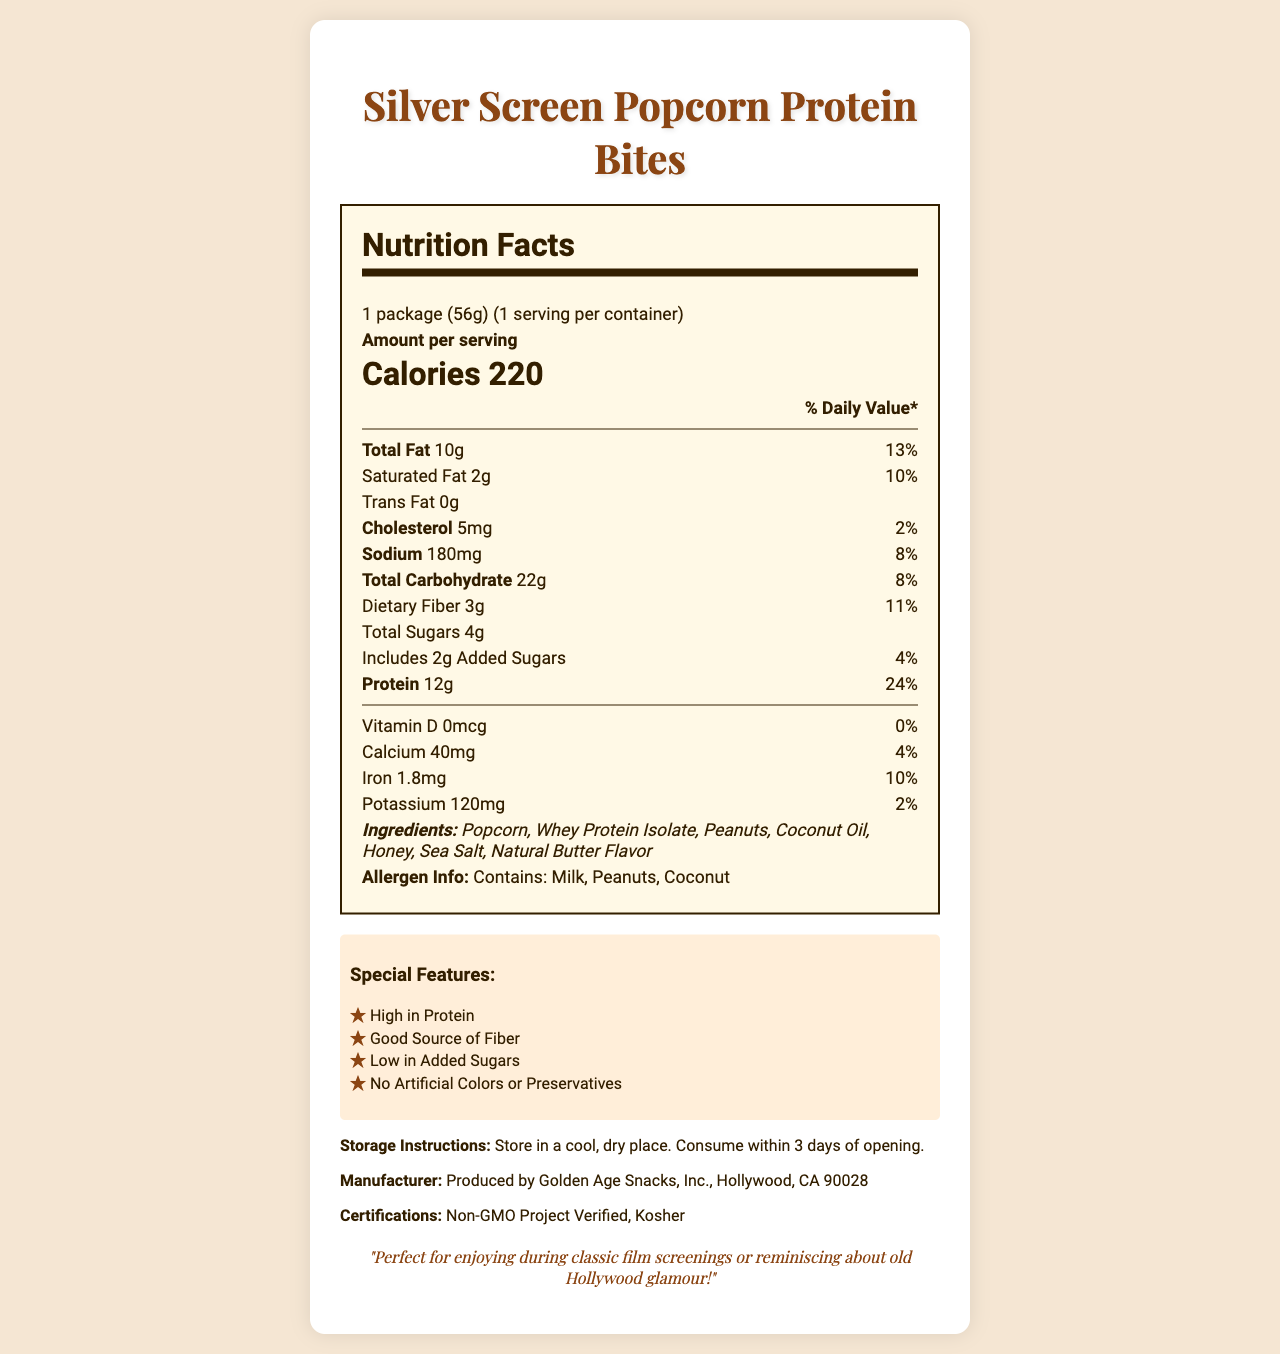what is the serving size of Silver Screen Popcorn Protein Bites? The serving size is specified directly in the Nutrition Facts Label at the top section.
Answer: 1 package (56g) how many calories are in one serving? The amount of calories per serving is highlighted in larger text under the "Amount per serving" section.
Answer: 220 calories what are the three main allergens in this product? The allergen info at the bottom of the Nutrition Facts Label explicitly states "Contains: Milk, Peanuts, Coconut".
Answer: Milk, Peanuts, Coconut what is the total fat content per serving? The total fat content is provided near the top of the label, stating "Total Fat 10g".
Answer: 10g how much protein does one serving contain? The document specifies "Protein 12g" under the nutrition facts, alongside the % Daily Value.
Answer: 12g which of the following is a special feature of the product? A. Contains Artificial Colors B. Low in Protein C. No Artificial Colors or Preservatives D. High in Added Sugars The special features listed include "No Artificial Colors or Preservatives" among other benefits.
Answer: C what is the daily value percentage of iron per serving? The daily value percentage for iron is listed on the label as "Iron 1.8mg" and "10%" in the vitamin and mineral section.
Answer: 10% True or False: This product includes artificial preservatives. Under the special features section, it states "No Artificial Colors or Preservatives".
Answer: False where is the manufacturer located? The manufacturer's information specifies "Golden Age Snacks, Inc., Hollywood, CA 90028".
Answer: Hollywood, CA 90028 how many grams of dietary fiber does this product contain? The nutritional label indicates "Dietary Fiber 3g", with an 11% daily value.
Answer: 3g does this product contain any added sugars? If yes, how many grams? The label indicates "Includes 2g Added Sugars" under the Total Sugars section.
Answer: Yes, 2g summarize the main features and highlights of the Silver Screen Popcorn Protein Bites. The summary covers the serving size, calorie content, protein and fiber amounts, special features, allergens, manufacturers, and certifications.
Answer: The Silver Screen Popcorn Protein Bites come in a 56g package and contain 220 calories per serving. They are high in protein (12g) and a good source of dietary fiber (3g) with low added sugars (2g). The product has no artificial colors or preservatives and contains allergens such as milk, peanuts, and coconut. It's manufactured by Golden Age Snacks, Inc. in Hollywood, CA, and is non-GMO and kosher certified. what type of movies would these snacks be perfect for according to the label? The movie night tip section suggests they are perfect for enjoying during classic film screenings or reminiscing about old Hollywood glamour.
Answer: Classic film screenings or reminiscing about old Hollywood glamour what is the recommended storage instruction for the product? The storage instructions provide exact directions on where and how long to store the product.
Answer: Store in a cool, dry place. Consume within 3 days of opening. How many calories do the added sugars contribute? The document does not provide information on the number of calories contributed specifically by the added sugars.
Answer: Cannot be determined 